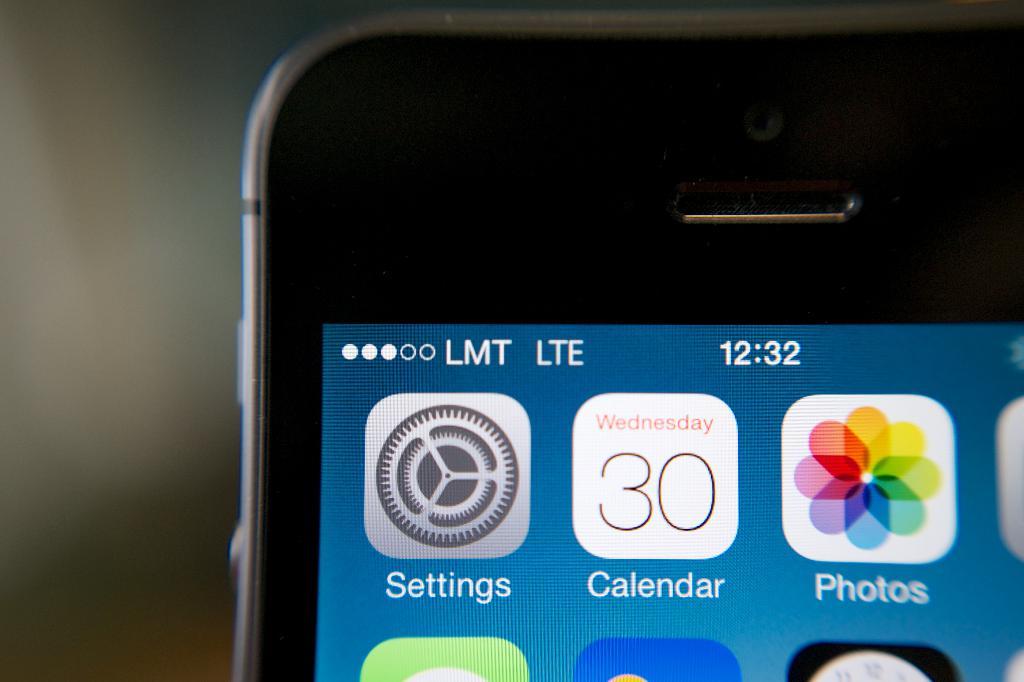What time is it?
Provide a succinct answer. 12:32. What is the date?
Provide a succinct answer. 30th. 